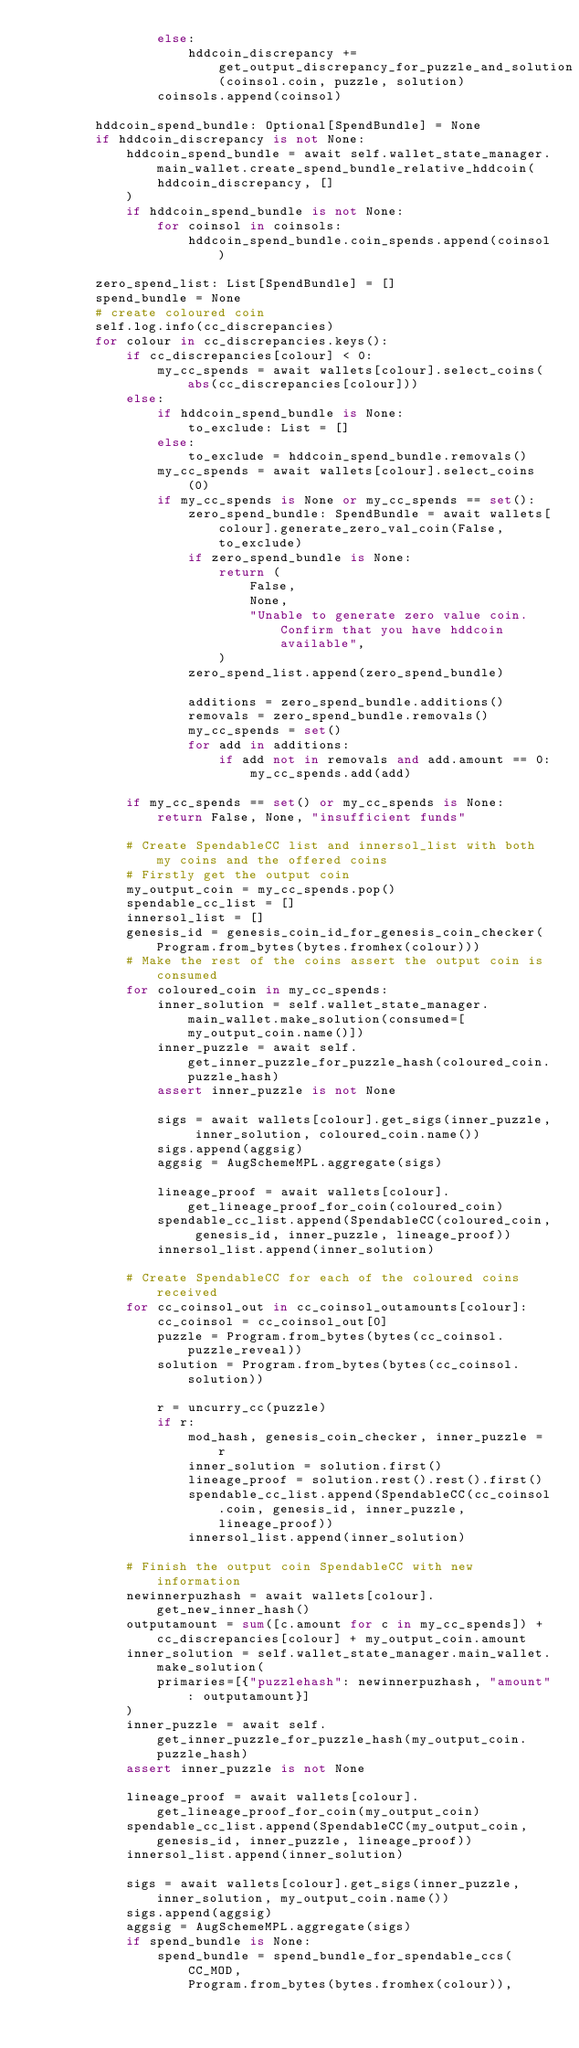Convert code to text. <code><loc_0><loc_0><loc_500><loc_500><_Python_>                else:
                    hddcoin_discrepancy += get_output_discrepancy_for_puzzle_and_solution(coinsol.coin, puzzle, solution)
                coinsols.append(coinsol)

        hddcoin_spend_bundle: Optional[SpendBundle] = None
        if hddcoin_discrepancy is not None:
            hddcoin_spend_bundle = await self.wallet_state_manager.main_wallet.create_spend_bundle_relative_hddcoin(
                hddcoin_discrepancy, []
            )
            if hddcoin_spend_bundle is not None:
                for coinsol in coinsols:
                    hddcoin_spend_bundle.coin_spends.append(coinsol)

        zero_spend_list: List[SpendBundle] = []
        spend_bundle = None
        # create coloured coin
        self.log.info(cc_discrepancies)
        for colour in cc_discrepancies.keys():
            if cc_discrepancies[colour] < 0:
                my_cc_spends = await wallets[colour].select_coins(abs(cc_discrepancies[colour]))
            else:
                if hddcoin_spend_bundle is None:
                    to_exclude: List = []
                else:
                    to_exclude = hddcoin_spend_bundle.removals()
                my_cc_spends = await wallets[colour].select_coins(0)
                if my_cc_spends is None or my_cc_spends == set():
                    zero_spend_bundle: SpendBundle = await wallets[colour].generate_zero_val_coin(False, to_exclude)
                    if zero_spend_bundle is None:
                        return (
                            False,
                            None,
                            "Unable to generate zero value coin. Confirm that you have hddcoin available",
                        )
                    zero_spend_list.append(zero_spend_bundle)

                    additions = zero_spend_bundle.additions()
                    removals = zero_spend_bundle.removals()
                    my_cc_spends = set()
                    for add in additions:
                        if add not in removals and add.amount == 0:
                            my_cc_spends.add(add)

            if my_cc_spends == set() or my_cc_spends is None:
                return False, None, "insufficient funds"

            # Create SpendableCC list and innersol_list with both my coins and the offered coins
            # Firstly get the output coin
            my_output_coin = my_cc_spends.pop()
            spendable_cc_list = []
            innersol_list = []
            genesis_id = genesis_coin_id_for_genesis_coin_checker(Program.from_bytes(bytes.fromhex(colour)))
            # Make the rest of the coins assert the output coin is consumed
            for coloured_coin in my_cc_spends:
                inner_solution = self.wallet_state_manager.main_wallet.make_solution(consumed=[my_output_coin.name()])
                inner_puzzle = await self.get_inner_puzzle_for_puzzle_hash(coloured_coin.puzzle_hash)
                assert inner_puzzle is not None

                sigs = await wallets[colour].get_sigs(inner_puzzle, inner_solution, coloured_coin.name())
                sigs.append(aggsig)
                aggsig = AugSchemeMPL.aggregate(sigs)

                lineage_proof = await wallets[colour].get_lineage_proof_for_coin(coloured_coin)
                spendable_cc_list.append(SpendableCC(coloured_coin, genesis_id, inner_puzzle, lineage_proof))
                innersol_list.append(inner_solution)

            # Create SpendableCC for each of the coloured coins received
            for cc_coinsol_out in cc_coinsol_outamounts[colour]:
                cc_coinsol = cc_coinsol_out[0]
                puzzle = Program.from_bytes(bytes(cc_coinsol.puzzle_reveal))
                solution = Program.from_bytes(bytes(cc_coinsol.solution))

                r = uncurry_cc(puzzle)
                if r:
                    mod_hash, genesis_coin_checker, inner_puzzle = r
                    inner_solution = solution.first()
                    lineage_proof = solution.rest().rest().first()
                    spendable_cc_list.append(SpendableCC(cc_coinsol.coin, genesis_id, inner_puzzle, lineage_proof))
                    innersol_list.append(inner_solution)

            # Finish the output coin SpendableCC with new information
            newinnerpuzhash = await wallets[colour].get_new_inner_hash()
            outputamount = sum([c.amount for c in my_cc_spends]) + cc_discrepancies[colour] + my_output_coin.amount
            inner_solution = self.wallet_state_manager.main_wallet.make_solution(
                primaries=[{"puzzlehash": newinnerpuzhash, "amount": outputamount}]
            )
            inner_puzzle = await self.get_inner_puzzle_for_puzzle_hash(my_output_coin.puzzle_hash)
            assert inner_puzzle is not None

            lineage_proof = await wallets[colour].get_lineage_proof_for_coin(my_output_coin)
            spendable_cc_list.append(SpendableCC(my_output_coin, genesis_id, inner_puzzle, lineage_proof))
            innersol_list.append(inner_solution)

            sigs = await wallets[colour].get_sigs(inner_puzzle, inner_solution, my_output_coin.name())
            sigs.append(aggsig)
            aggsig = AugSchemeMPL.aggregate(sigs)
            if spend_bundle is None:
                spend_bundle = spend_bundle_for_spendable_ccs(
                    CC_MOD,
                    Program.from_bytes(bytes.fromhex(colour)),</code> 